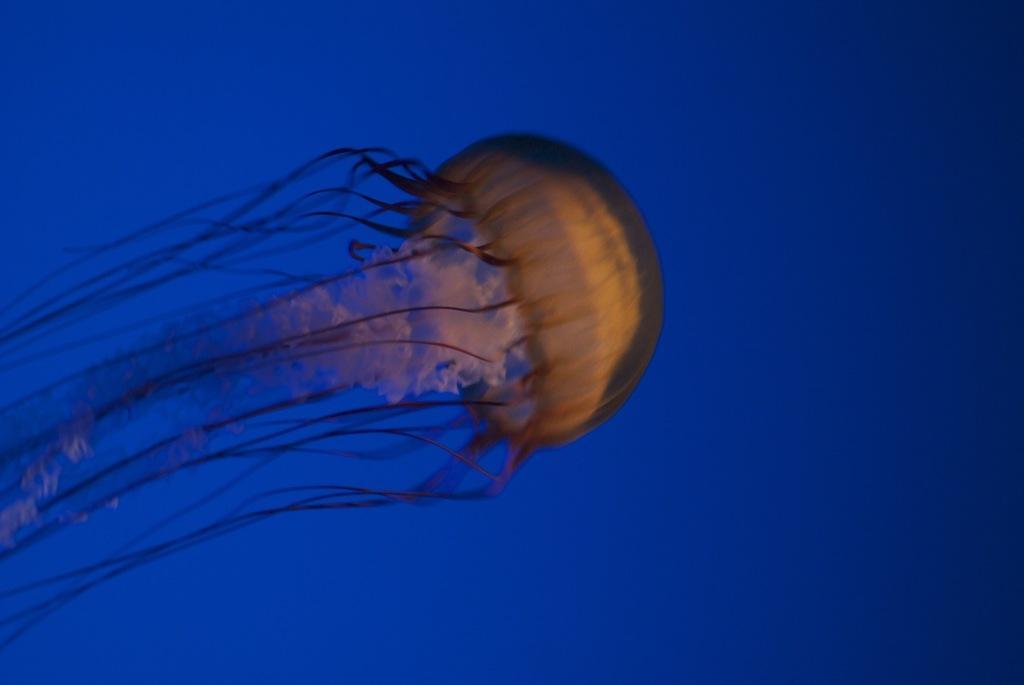Describe this image in one or two sentences. In this picture we can see a jellyfish and behind the jellyfish there is a blue background. 